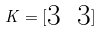<formula> <loc_0><loc_0><loc_500><loc_500>K = [ \begin{matrix} 3 & 3 \end{matrix} ]</formula> 